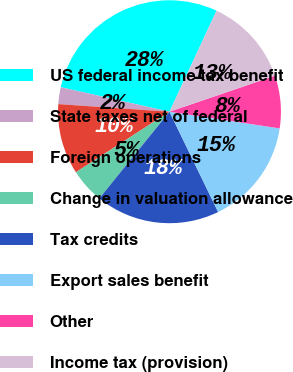<chart> <loc_0><loc_0><loc_500><loc_500><pie_chart><fcel>US federal income tax benefit<fcel>State taxes net of federal<fcel>Foreign operations<fcel>Change in valuation allowance<fcel>Tax credits<fcel>Export sales benefit<fcel>Other<fcel>Income tax (provision)<nl><fcel>28.41%<fcel>2.44%<fcel>10.23%<fcel>5.03%<fcel>18.02%<fcel>15.42%<fcel>7.63%<fcel>12.82%<nl></chart> 